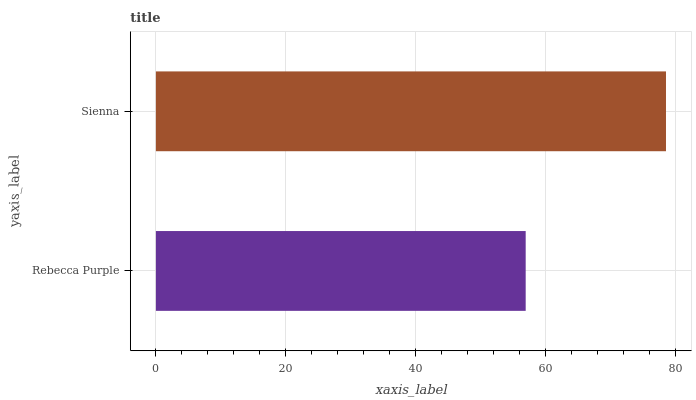Is Rebecca Purple the minimum?
Answer yes or no. Yes. Is Sienna the maximum?
Answer yes or no. Yes. Is Sienna the minimum?
Answer yes or no. No. Is Sienna greater than Rebecca Purple?
Answer yes or no. Yes. Is Rebecca Purple less than Sienna?
Answer yes or no. Yes. Is Rebecca Purple greater than Sienna?
Answer yes or no. No. Is Sienna less than Rebecca Purple?
Answer yes or no. No. Is Sienna the high median?
Answer yes or no. Yes. Is Rebecca Purple the low median?
Answer yes or no. Yes. Is Rebecca Purple the high median?
Answer yes or no. No. Is Sienna the low median?
Answer yes or no. No. 